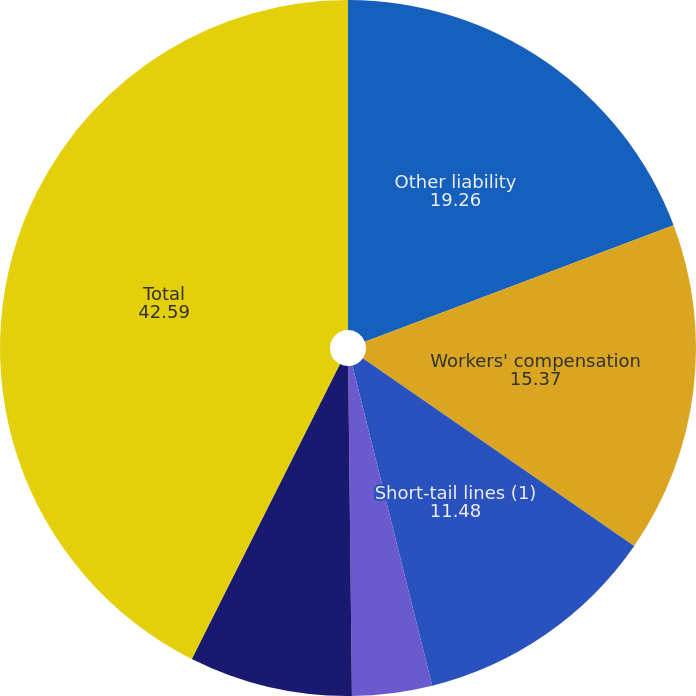Convert chart. <chart><loc_0><loc_0><loc_500><loc_500><pie_chart><fcel>Other liability<fcel>Workers' compensation<fcel>Short-tail lines (1)<fcel>Professional liability<fcel>Commercial auto<fcel>Total<nl><fcel>19.26%<fcel>15.37%<fcel>11.48%<fcel>3.71%<fcel>7.59%<fcel>42.59%<nl></chart> 